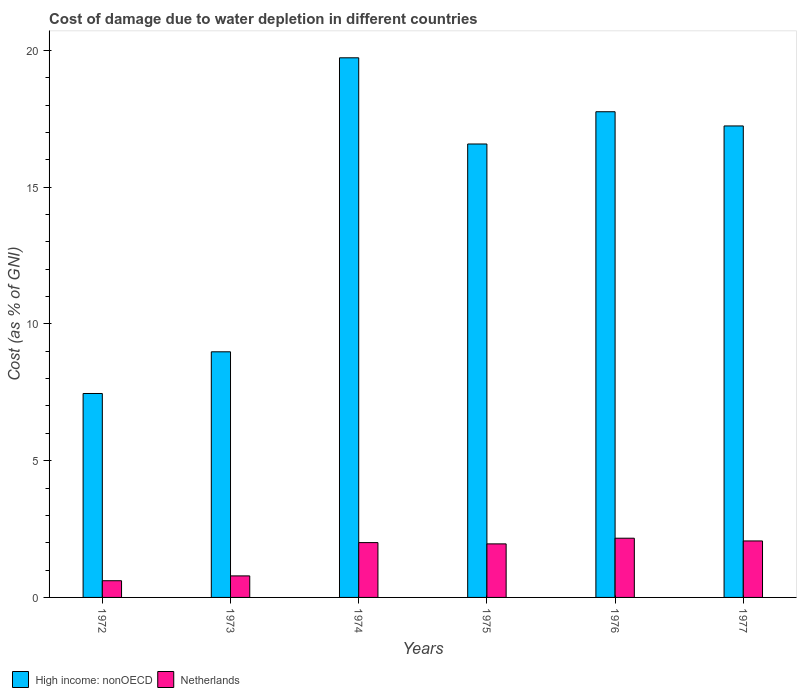How many different coloured bars are there?
Your answer should be very brief. 2. Are the number of bars on each tick of the X-axis equal?
Ensure brevity in your answer.  Yes. What is the label of the 2nd group of bars from the left?
Offer a very short reply. 1973. In how many cases, is the number of bars for a given year not equal to the number of legend labels?
Offer a terse response. 0. What is the cost of damage caused due to water depletion in High income: nonOECD in 1974?
Give a very brief answer. 19.73. Across all years, what is the maximum cost of damage caused due to water depletion in High income: nonOECD?
Your answer should be compact. 19.73. Across all years, what is the minimum cost of damage caused due to water depletion in Netherlands?
Offer a terse response. 0.61. In which year was the cost of damage caused due to water depletion in High income: nonOECD maximum?
Your answer should be very brief. 1974. In which year was the cost of damage caused due to water depletion in High income: nonOECD minimum?
Give a very brief answer. 1972. What is the total cost of damage caused due to water depletion in High income: nonOECD in the graph?
Your response must be concise. 87.72. What is the difference between the cost of damage caused due to water depletion in Netherlands in 1973 and that in 1974?
Provide a short and direct response. -1.22. What is the difference between the cost of damage caused due to water depletion in Netherlands in 1976 and the cost of damage caused due to water depletion in High income: nonOECD in 1972?
Give a very brief answer. -5.29. What is the average cost of damage caused due to water depletion in Netherlands per year?
Offer a terse response. 1.6. In the year 1976, what is the difference between the cost of damage caused due to water depletion in Netherlands and cost of damage caused due to water depletion in High income: nonOECD?
Your answer should be compact. -15.59. What is the ratio of the cost of damage caused due to water depletion in Netherlands in 1973 to that in 1976?
Ensure brevity in your answer.  0.36. What is the difference between the highest and the second highest cost of damage caused due to water depletion in High income: nonOECD?
Make the answer very short. 1.97. What is the difference between the highest and the lowest cost of damage caused due to water depletion in Netherlands?
Give a very brief answer. 1.55. What does the 2nd bar from the left in 1972 represents?
Offer a terse response. Netherlands. Where does the legend appear in the graph?
Ensure brevity in your answer.  Bottom left. How are the legend labels stacked?
Offer a very short reply. Horizontal. What is the title of the graph?
Keep it short and to the point. Cost of damage due to water depletion in different countries. What is the label or title of the Y-axis?
Offer a terse response. Cost (as % of GNI). What is the Cost (as % of GNI) in High income: nonOECD in 1972?
Give a very brief answer. 7.45. What is the Cost (as % of GNI) in Netherlands in 1972?
Offer a very short reply. 0.61. What is the Cost (as % of GNI) of High income: nonOECD in 1973?
Provide a succinct answer. 8.98. What is the Cost (as % of GNI) in Netherlands in 1973?
Provide a short and direct response. 0.79. What is the Cost (as % of GNI) of High income: nonOECD in 1974?
Your answer should be compact. 19.73. What is the Cost (as % of GNI) of Netherlands in 1974?
Your response must be concise. 2. What is the Cost (as % of GNI) in High income: nonOECD in 1975?
Your answer should be very brief. 16.58. What is the Cost (as % of GNI) in Netherlands in 1975?
Ensure brevity in your answer.  1.96. What is the Cost (as % of GNI) in High income: nonOECD in 1976?
Your answer should be very brief. 17.75. What is the Cost (as % of GNI) of Netherlands in 1976?
Provide a short and direct response. 2.16. What is the Cost (as % of GNI) of High income: nonOECD in 1977?
Your answer should be compact. 17.23. What is the Cost (as % of GNI) of Netherlands in 1977?
Your answer should be compact. 2.06. Across all years, what is the maximum Cost (as % of GNI) of High income: nonOECD?
Your answer should be very brief. 19.73. Across all years, what is the maximum Cost (as % of GNI) of Netherlands?
Your answer should be very brief. 2.16. Across all years, what is the minimum Cost (as % of GNI) of High income: nonOECD?
Offer a terse response. 7.45. Across all years, what is the minimum Cost (as % of GNI) in Netherlands?
Your answer should be compact. 0.61. What is the total Cost (as % of GNI) of High income: nonOECD in the graph?
Your response must be concise. 87.72. What is the total Cost (as % of GNI) of Netherlands in the graph?
Your response must be concise. 9.59. What is the difference between the Cost (as % of GNI) in High income: nonOECD in 1972 and that in 1973?
Your answer should be very brief. -1.52. What is the difference between the Cost (as % of GNI) in Netherlands in 1972 and that in 1973?
Offer a terse response. -0.18. What is the difference between the Cost (as % of GNI) of High income: nonOECD in 1972 and that in 1974?
Offer a very short reply. -12.27. What is the difference between the Cost (as % of GNI) in Netherlands in 1972 and that in 1974?
Your response must be concise. -1.39. What is the difference between the Cost (as % of GNI) in High income: nonOECD in 1972 and that in 1975?
Your answer should be compact. -9.12. What is the difference between the Cost (as % of GNI) in Netherlands in 1972 and that in 1975?
Keep it short and to the point. -1.35. What is the difference between the Cost (as % of GNI) in High income: nonOECD in 1972 and that in 1976?
Your answer should be compact. -10.3. What is the difference between the Cost (as % of GNI) in Netherlands in 1972 and that in 1976?
Your answer should be compact. -1.55. What is the difference between the Cost (as % of GNI) of High income: nonOECD in 1972 and that in 1977?
Provide a succinct answer. -9.78. What is the difference between the Cost (as % of GNI) in Netherlands in 1972 and that in 1977?
Give a very brief answer. -1.45. What is the difference between the Cost (as % of GNI) in High income: nonOECD in 1973 and that in 1974?
Provide a succinct answer. -10.75. What is the difference between the Cost (as % of GNI) in Netherlands in 1973 and that in 1974?
Ensure brevity in your answer.  -1.22. What is the difference between the Cost (as % of GNI) of High income: nonOECD in 1973 and that in 1975?
Make the answer very short. -7.6. What is the difference between the Cost (as % of GNI) in Netherlands in 1973 and that in 1975?
Ensure brevity in your answer.  -1.17. What is the difference between the Cost (as % of GNI) in High income: nonOECD in 1973 and that in 1976?
Your answer should be very brief. -8.78. What is the difference between the Cost (as % of GNI) in Netherlands in 1973 and that in 1976?
Your answer should be compact. -1.38. What is the difference between the Cost (as % of GNI) in High income: nonOECD in 1973 and that in 1977?
Offer a terse response. -8.26. What is the difference between the Cost (as % of GNI) in Netherlands in 1973 and that in 1977?
Provide a succinct answer. -1.28. What is the difference between the Cost (as % of GNI) in High income: nonOECD in 1974 and that in 1975?
Give a very brief answer. 3.15. What is the difference between the Cost (as % of GNI) in Netherlands in 1974 and that in 1975?
Your answer should be very brief. 0.05. What is the difference between the Cost (as % of GNI) in High income: nonOECD in 1974 and that in 1976?
Give a very brief answer. 1.97. What is the difference between the Cost (as % of GNI) of Netherlands in 1974 and that in 1976?
Make the answer very short. -0.16. What is the difference between the Cost (as % of GNI) of High income: nonOECD in 1974 and that in 1977?
Ensure brevity in your answer.  2.49. What is the difference between the Cost (as % of GNI) of Netherlands in 1974 and that in 1977?
Give a very brief answer. -0.06. What is the difference between the Cost (as % of GNI) in High income: nonOECD in 1975 and that in 1976?
Give a very brief answer. -1.18. What is the difference between the Cost (as % of GNI) of Netherlands in 1975 and that in 1976?
Your answer should be compact. -0.21. What is the difference between the Cost (as % of GNI) in High income: nonOECD in 1975 and that in 1977?
Your answer should be compact. -0.66. What is the difference between the Cost (as % of GNI) in Netherlands in 1975 and that in 1977?
Keep it short and to the point. -0.11. What is the difference between the Cost (as % of GNI) in High income: nonOECD in 1976 and that in 1977?
Make the answer very short. 0.52. What is the difference between the Cost (as % of GNI) of Netherlands in 1976 and that in 1977?
Your answer should be very brief. 0.1. What is the difference between the Cost (as % of GNI) of High income: nonOECD in 1972 and the Cost (as % of GNI) of Netherlands in 1973?
Provide a short and direct response. 6.67. What is the difference between the Cost (as % of GNI) of High income: nonOECD in 1972 and the Cost (as % of GNI) of Netherlands in 1974?
Provide a succinct answer. 5.45. What is the difference between the Cost (as % of GNI) in High income: nonOECD in 1972 and the Cost (as % of GNI) in Netherlands in 1975?
Provide a short and direct response. 5.5. What is the difference between the Cost (as % of GNI) of High income: nonOECD in 1972 and the Cost (as % of GNI) of Netherlands in 1976?
Offer a terse response. 5.29. What is the difference between the Cost (as % of GNI) of High income: nonOECD in 1972 and the Cost (as % of GNI) of Netherlands in 1977?
Keep it short and to the point. 5.39. What is the difference between the Cost (as % of GNI) in High income: nonOECD in 1973 and the Cost (as % of GNI) in Netherlands in 1974?
Give a very brief answer. 6.97. What is the difference between the Cost (as % of GNI) in High income: nonOECD in 1973 and the Cost (as % of GNI) in Netherlands in 1975?
Your answer should be very brief. 7.02. What is the difference between the Cost (as % of GNI) of High income: nonOECD in 1973 and the Cost (as % of GNI) of Netherlands in 1976?
Make the answer very short. 6.81. What is the difference between the Cost (as % of GNI) of High income: nonOECD in 1973 and the Cost (as % of GNI) of Netherlands in 1977?
Make the answer very short. 6.91. What is the difference between the Cost (as % of GNI) in High income: nonOECD in 1974 and the Cost (as % of GNI) in Netherlands in 1975?
Your response must be concise. 17.77. What is the difference between the Cost (as % of GNI) in High income: nonOECD in 1974 and the Cost (as % of GNI) in Netherlands in 1976?
Your answer should be very brief. 17.56. What is the difference between the Cost (as % of GNI) of High income: nonOECD in 1974 and the Cost (as % of GNI) of Netherlands in 1977?
Make the answer very short. 17.66. What is the difference between the Cost (as % of GNI) in High income: nonOECD in 1975 and the Cost (as % of GNI) in Netherlands in 1976?
Offer a very short reply. 14.41. What is the difference between the Cost (as % of GNI) of High income: nonOECD in 1975 and the Cost (as % of GNI) of Netherlands in 1977?
Provide a succinct answer. 14.51. What is the difference between the Cost (as % of GNI) of High income: nonOECD in 1976 and the Cost (as % of GNI) of Netherlands in 1977?
Your answer should be very brief. 15.69. What is the average Cost (as % of GNI) in High income: nonOECD per year?
Offer a terse response. 14.62. What is the average Cost (as % of GNI) in Netherlands per year?
Your answer should be compact. 1.6. In the year 1972, what is the difference between the Cost (as % of GNI) of High income: nonOECD and Cost (as % of GNI) of Netherlands?
Your response must be concise. 6.84. In the year 1973, what is the difference between the Cost (as % of GNI) in High income: nonOECD and Cost (as % of GNI) in Netherlands?
Your answer should be very brief. 8.19. In the year 1974, what is the difference between the Cost (as % of GNI) in High income: nonOECD and Cost (as % of GNI) in Netherlands?
Keep it short and to the point. 17.72. In the year 1975, what is the difference between the Cost (as % of GNI) of High income: nonOECD and Cost (as % of GNI) of Netherlands?
Your answer should be very brief. 14.62. In the year 1976, what is the difference between the Cost (as % of GNI) in High income: nonOECD and Cost (as % of GNI) in Netherlands?
Provide a succinct answer. 15.59. In the year 1977, what is the difference between the Cost (as % of GNI) of High income: nonOECD and Cost (as % of GNI) of Netherlands?
Give a very brief answer. 15.17. What is the ratio of the Cost (as % of GNI) in High income: nonOECD in 1972 to that in 1973?
Ensure brevity in your answer.  0.83. What is the ratio of the Cost (as % of GNI) of Netherlands in 1972 to that in 1973?
Your response must be concise. 0.78. What is the ratio of the Cost (as % of GNI) in High income: nonOECD in 1972 to that in 1974?
Offer a very short reply. 0.38. What is the ratio of the Cost (as % of GNI) of Netherlands in 1972 to that in 1974?
Provide a short and direct response. 0.3. What is the ratio of the Cost (as % of GNI) of High income: nonOECD in 1972 to that in 1975?
Your response must be concise. 0.45. What is the ratio of the Cost (as % of GNI) of Netherlands in 1972 to that in 1975?
Provide a short and direct response. 0.31. What is the ratio of the Cost (as % of GNI) in High income: nonOECD in 1972 to that in 1976?
Your answer should be very brief. 0.42. What is the ratio of the Cost (as % of GNI) in Netherlands in 1972 to that in 1976?
Provide a short and direct response. 0.28. What is the ratio of the Cost (as % of GNI) in High income: nonOECD in 1972 to that in 1977?
Offer a very short reply. 0.43. What is the ratio of the Cost (as % of GNI) in Netherlands in 1972 to that in 1977?
Your answer should be very brief. 0.3. What is the ratio of the Cost (as % of GNI) of High income: nonOECD in 1973 to that in 1974?
Offer a terse response. 0.46. What is the ratio of the Cost (as % of GNI) of Netherlands in 1973 to that in 1974?
Your response must be concise. 0.39. What is the ratio of the Cost (as % of GNI) in High income: nonOECD in 1973 to that in 1975?
Give a very brief answer. 0.54. What is the ratio of the Cost (as % of GNI) of Netherlands in 1973 to that in 1975?
Make the answer very short. 0.4. What is the ratio of the Cost (as % of GNI) of High income: nonOECD in 1973 to that in 1976?
Make the answer very short. 0.51. What is the ratio of the Cost (as % of GNI) in Netherlands in 1973 to that in 1976?
Ensure brevity in your answer.  0.36. What is the ratio of the Cost (as % of GNI) of High income: nonOECD in 1973 to that in 1977?
Your answer should be compact. 0.52. What is the ratio of the Cost (as % of GNI) in Netherlands in 1973 to that in 1977?
Make the answer very short. 0.38. What is the ratio of the Cost (as % of GNI) of High income: nonOECD in 1974 to that in 1975?
Make the answer very short. 1.19. What is the ratio of the Cost (as % of GNI) in Netherlands in 1974 to that in 1975?
Give a very brief answer. 1.02. What is the ratio of the Cost (as % of GNI) of Netherlands in 1974 to that in 1976?
Your answer should be compact. 0.93. What is the ratio of the Cost (as % of GNI) of High income: nonOECD in 1974 to that in 1977?
Provide a short and direct response. 1.14. What is the ratio of the Cost (as % of GNI) of Netherlands in 1974 to that in 1977?
Make the answer very short. 0.97. What is the ratio of the Cost (as % of GNI) in High income: nonOECD in 1975 to that in 1976?
Your answer should be very brief. 0.93. What is the ratio of the Cost (as % of GNI) in Netherlands in 1975 to that in 1976?
Your answer should be compact. 0.9. What is the ratio of the Cost (as % of GNI) of High income: nonOECD in 1975 to that in 1977?
Give a very brief answer. 0.96. What is the ratio of the Cost (as % of GNI) in Netherlands in 1975 to that in 1977?
Make the answer very short. 0.95. What is the ratio of the Cost (as % of GNI) of High income: nonOECD in 1976 to that in 1977?
Make the answer very short. 1.03. What is the ratio of the Cost (as % of GNI) in Netherlands in 1976 to that in 1977?
Ensure brevity in your answer.  1.05. What is the difference between the highest and the second highest Cost (as % of GNI) of High income: nonOECD?
Make the answer very short. 1.97. What is the difference between the highest and the second highest Cost (as % of GNI) of Netherlands?
Provide a succinct answer. 0.1. What is the difference between the highest and the lowest Cost (as % of GNI) of High income: nonOECD?
Your response must be concise. 12.27. What is the difference between the highest and the lowest Cost (as % of GNI) in Netherlands?
Your answer should be compact. 1.55. 